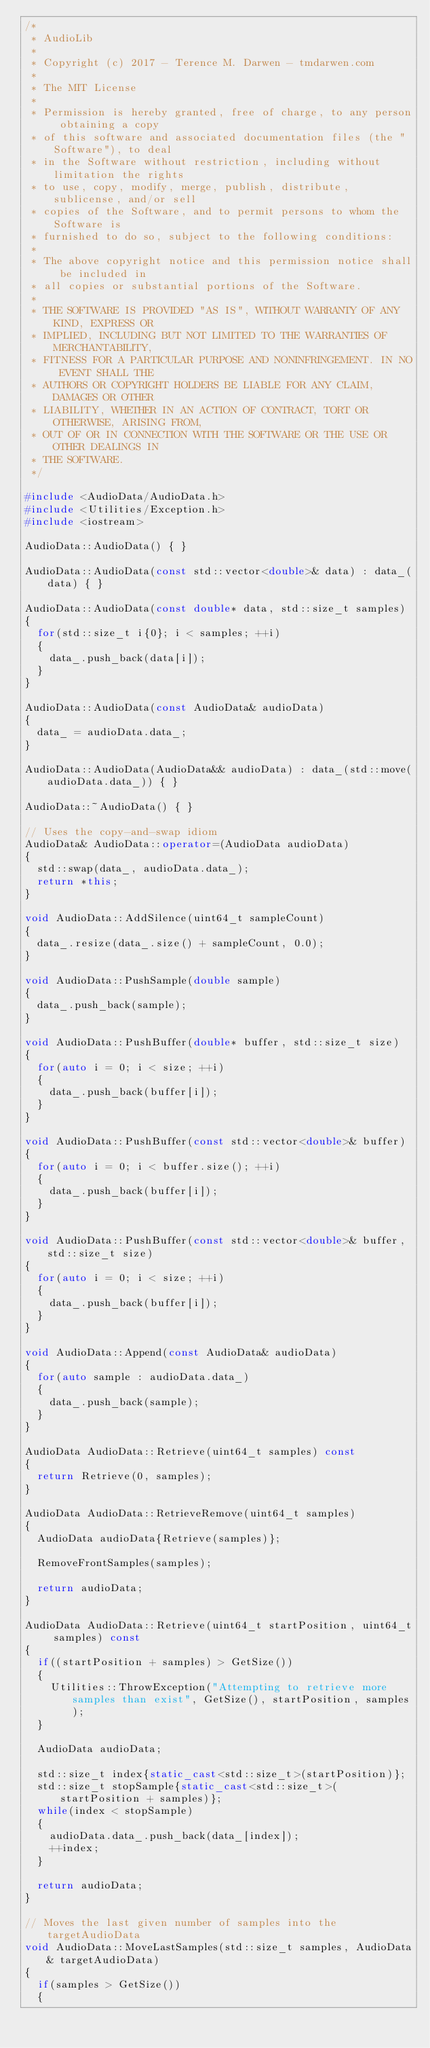<code> <loc_0><loc_0><loc_500><loc_500><_C++_>/*
 * AudioLib
 *
 * Copyright (c) 2017 - Terence M. Darwen - tmdarwen.com
 *
 * The MIT License
 *
 * Permission is hereby granted, free of charge, to any person obtaining a copy
 * of this software and associated documentation files (the "Software"), to deal
 * in the Software without restriction, including without limitation the rights
 * to use, copy, modify, merge, publish, distribute, sublicense, and/or sell
 * copies of the Software, and to permit persons to whom the Software is
 * furnished to do so, subject to the following conditions:
 *
 * The above copyright notice and this permission notice shall be included in
 * all copies or substantial portions of the Software.
 *
 * THE SOFTWARE IS PROVIDED "AS IS", WITHOUT WARRANTY OF ANY KIND, EXPRESS OR
 * IMPLIED, INCLUDING BUT NOT LIMITED TO THE WARRANTIES OF MERCHANTABILITY,
 * FITNESS FOR A PARTICULAR PURPOSE AND NONINFRINGEMENT. IN NO EVENT SHALL THE
 * AUTHORS OR COPYRIGHT HOLDERS BE LIABLE FOR ANY CLAIM, DAMAGES OR OTHER
 * LIABILITY, WHETHER IN AN ACTION OF CONTRACT, TORT OR OTHERWISE, ARISING FROM,
 * OUT OF OR IN CONNECTION WITH THE SOFTWARE OR THE USE OR OTHER DEALINGS IN
 * THE SOFTWARE.
 */

#include <AudioData/AudioData.h>
#include <Utilities/Exception.h>
#include <iostream>

AudioData::AudioData() { }

AudioData::AudioData(const std::vector<double>& data) : data_(data) { }

AudioData::AudioData(const double* data, std::size_t samples) 
{
	for(std::size_t i{0}; i < samples; ++i)
	{
		data_.push_back(data[i]);
	}
}

AudioData::AudioData(const AudioData& audioData)
{
	data_ = audioData.data_;
}

AudioData::AudioData(AudioData&& audioData) : data_(std::move(audioData.data_)) { }

AudioData::~AudioData() { }

// Uses the copy-and-swap idiom
AudioData& AudioData::operator=(AudioData audioData)
{
	std::swap(data_, audioData.data_);
	return *this;
}

void AudioData::AddSilence(uint64_t sampleCount)
{
	data_.resize(data_.size() + sampleCount, 0.0);
}

void AudioData::PushSample(double sample)
{
	data_.push_back(sample);
}

void AudioData::PushBuffer(double* buffer, std::size_t size)
{
	for(auto i = 0; i < size; ++i)
	{
		data_.push_back(buffer[i]);
	}
}

void AudioData::PushBuffer(const std::vector<double>& buffer)
{
	for(auto i = 0; i < buffer.size(); ++i)
	{
		data_.push_back(buffer[i]);
	}
}

void AudioData::PushBuffer(const std::vector<double>& buffer, std::size_t size)
{
	for(auto i = 0; i < size; ++i)
	{
		data_.push_back(buffer[i]);
	}
}

void AudioData::Append(const AudioData& audioData)
{
	for(auto sample : audioData.data_)
	{
		data_.push_back(sample);	
	}
}

AudioData AudioData::Retrieve(uint64_t samples) const
{
	return Retrieve(0, samples);
}

AudioData AudioData::RetrieveRemove(uint64_t samples)
{
	AudioData audioData{Retrieve(samples)};

	RemoveFrontSamples(samples);

	return audioData;
}

AudioData AudioData::Retrieve(uint64_t startPosition, uint64_t samples) const
{
	if((startPosition + samples) > GetSize())
	{
		Utilities::ThrowException("Attempting to retrieve more samples than exist", GetSize(), startPosition, samples);
	}

	AudioData audioData;

	std::size_t index{static_cast<std::size_t>(startPosition)};
	std::size_t stopSample{static_cast<std::size_t>(startPosition + samples)};
	while(index < stopSample)
	{
		audioData.data_.push_back(data_[index]);	
		++index;
	}

	return audioData;
}

// Moves the last given number of samples into the targetAudioData
void AudioData::MoveLastSamples(std::size_t samples, AudioData& targetAudioData)
{
	if(samples > GetSize())
	{</code> 